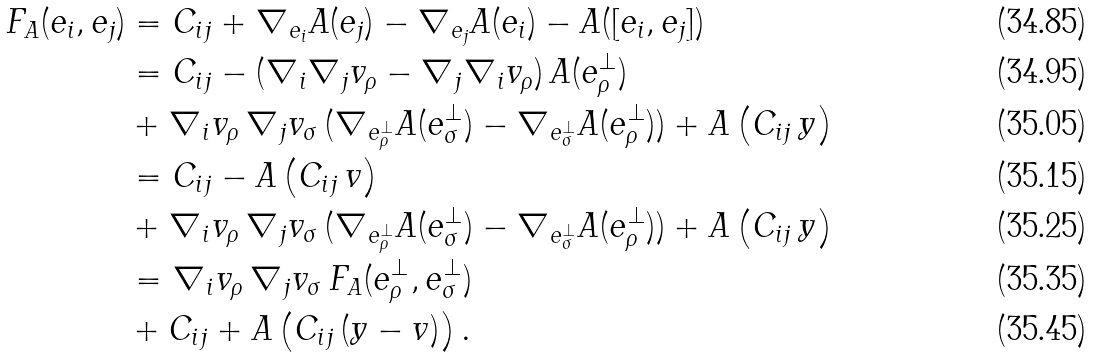<formula> <loc_0><loc_0><loc_500><loc_500>F _ { A } ( e _ { i } , e _ { j } ) & = C _ { i j } + \nabla _ { e _ { i } } A ( e _ { j } ) - \nabla _ { e _ { j } } A ( e _ { i } ) - A ( [ e _ { i } , e _ { j } ] ) \\ & = C _ { i j } - ( \nabla _ { i } \nabla _ { j } v _ { \rho } - \nabla _ { j } \nabla _ { i } v _ { \rho } ) \, A ( e _ { \rho } ^ { \perp } ) \\ & + \nabla _ { i } v _ { \rho } \, \nabla _ { j } v _ { \sigma } \, ( \nabla _ { e _ { \rho } ^ { \perp } } A ( e _ { \sigma } ^ { \perp } ) - \nabla _ { e _ { \sigma } ^ { \perp } } A ( e _ { \rho } ^ { \perp } ) ) + A \left ( C _ { i j } \, y \right ) \\ & = C _ { i j } - A \left ( C _ { i j } \, v \right ) \\ & + \nabla _ { i } v _ { \rho } \, \nabla _ { j } v _ { \sigma } \, ( \nabla _ { e _ { \rho } ^ { \perp } } A ( e _ { \sigma } ^ { \perp } ) - \nabla _ { e _ { \sigma } ^ { \perp } } A ( e _ { \rho } ^ { \perp } ) ) + A \left ( C _ { i j } \, y \right ) \\ & = \nabla _ { i } v _ { \rho } \, \nabla _ { j } v _ { \sigma } \, F _ { A } ( e _ { \rho } ^ { \perp } , e _ { \sigma } ^ { \perp } ) \\ & + C _ { i j } + A \left ( C _ { i j } \, ( y - v ) \right ) .</formula> 